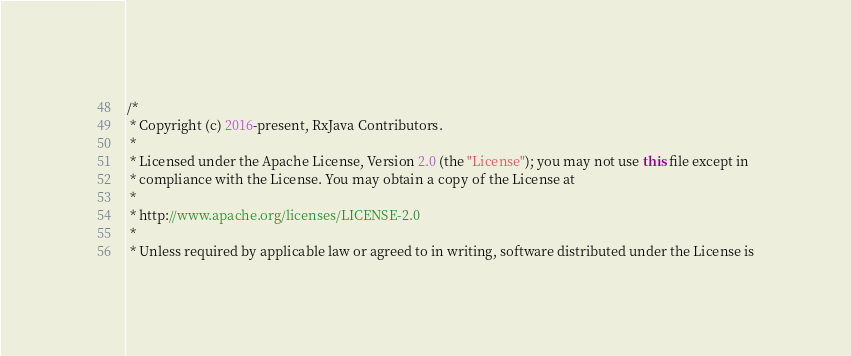<code> <loc_0><loc_0><loc_500><loc_500><_Java_>/*
 * Copyright (c) 2016-present, RxJava Contributors.
 *
 * Licensed under the Apache License, Version 2.0 (the "License"); you may not use this file except in
 * compliance with the License. You may obtain a copy of the License at
 *
 * http://www.apache.org/licenses/LICENSE-2.0
 *
 * Unless required by applicable law or agreed to in writing, software distributed under the License is</code> 